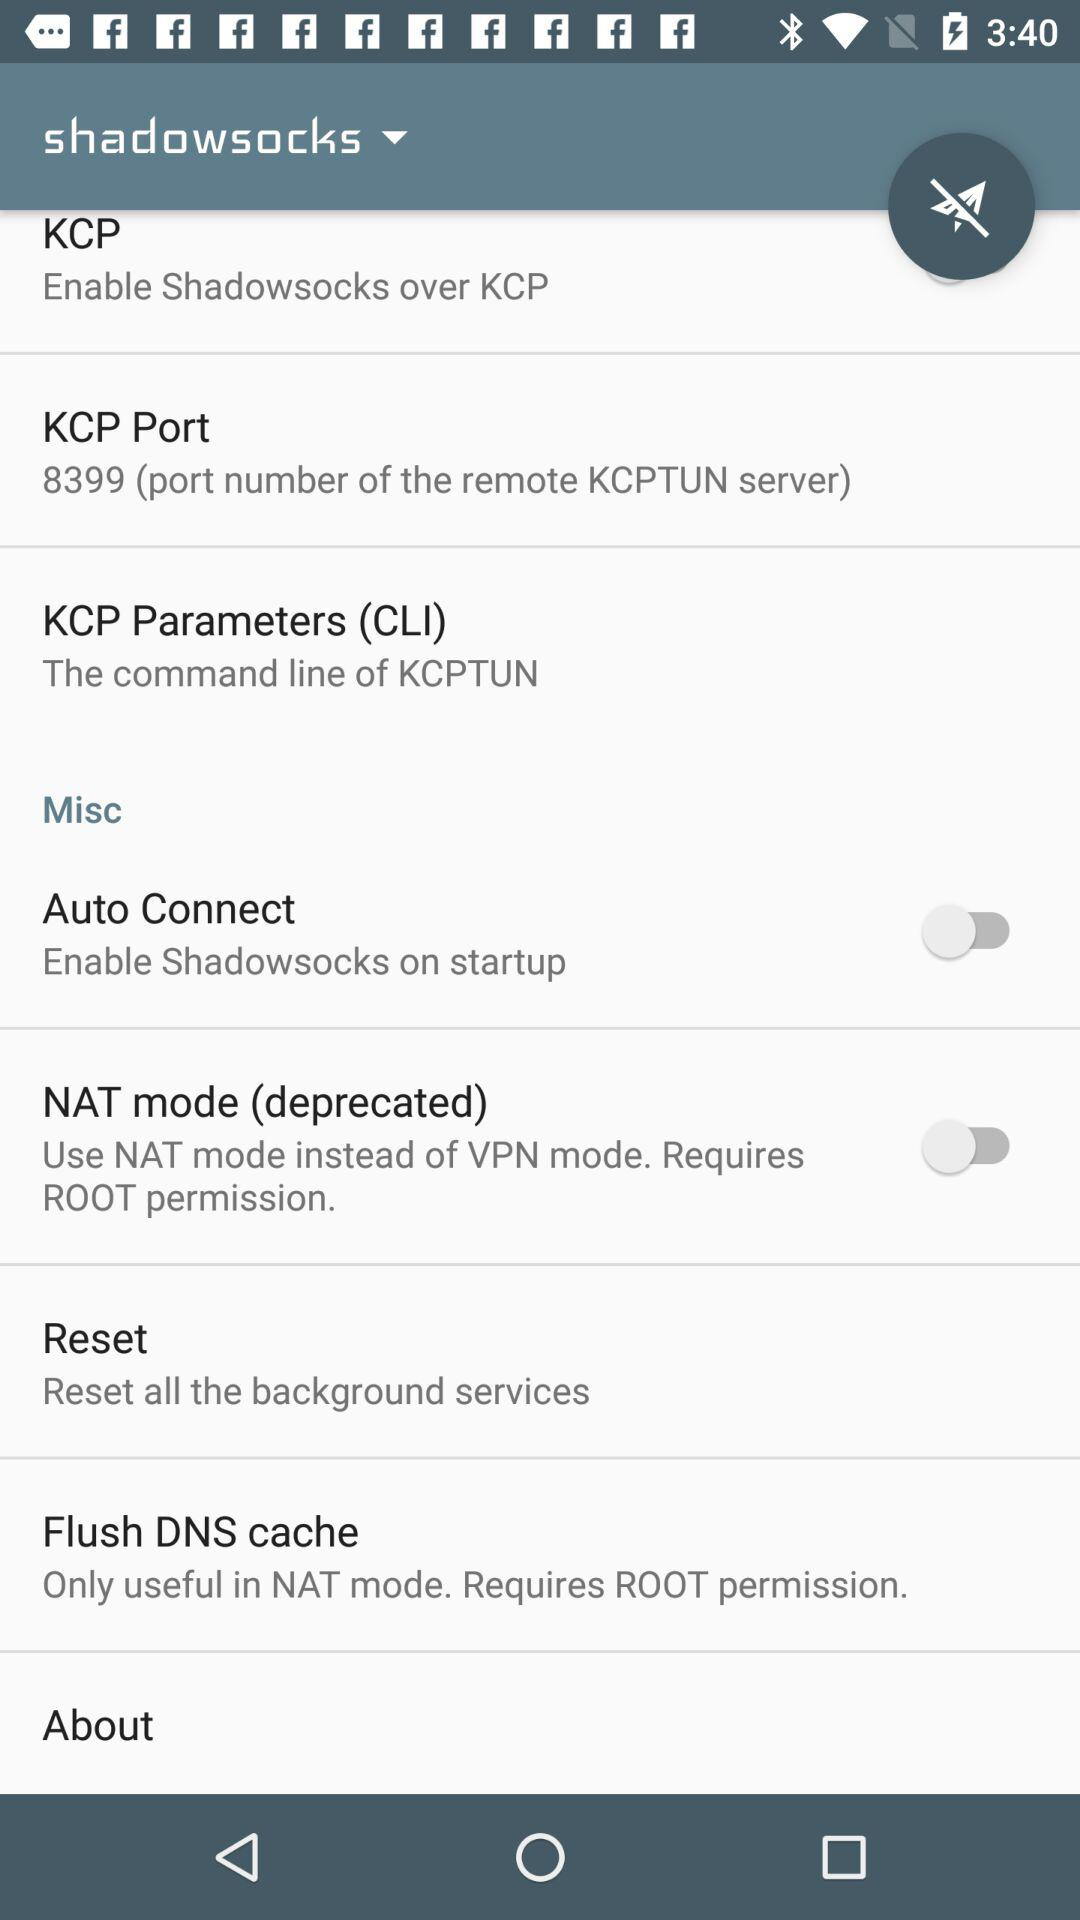What is the KCP port number? The KCP port number is 8399. 